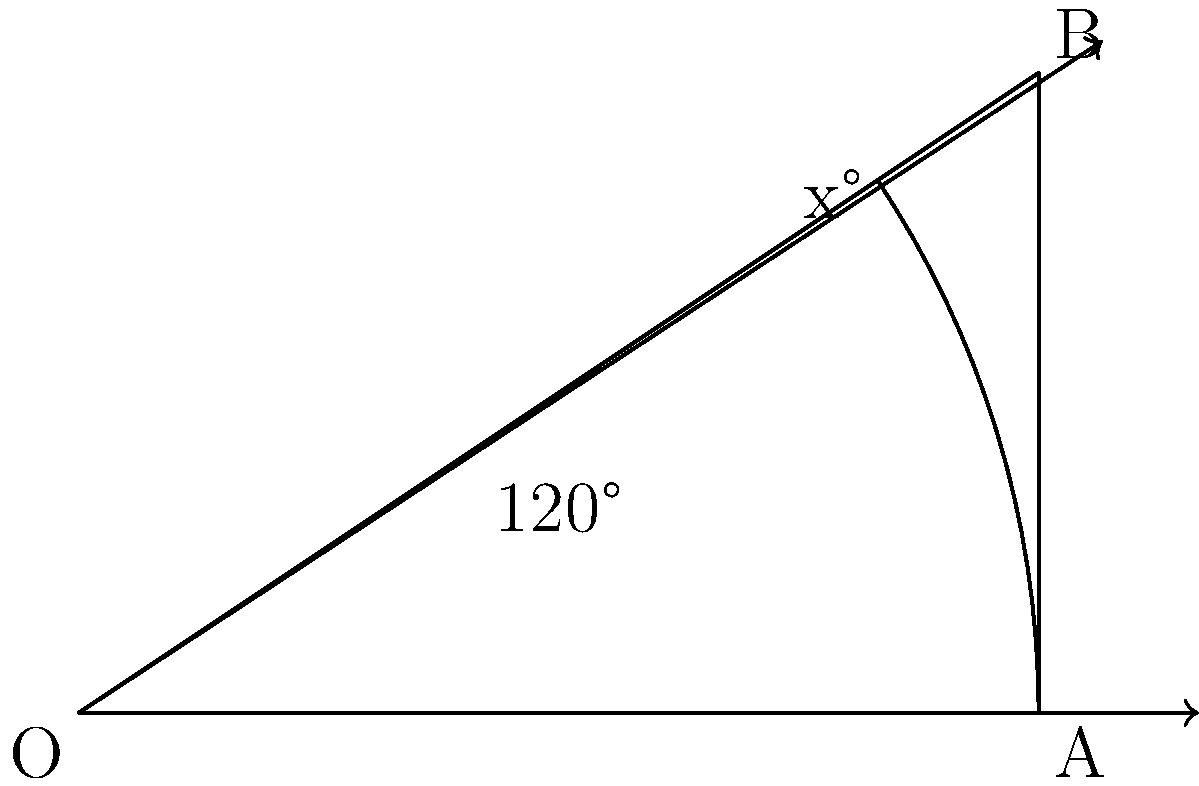In your latest VR game, you need to calculate the field of view (FOV) angle for a new headset. Given that the horizontal FOV is 120° and the aspect ratio of the display is 3:2, what is the vertical FOV angle (x°) to the nearest whole degree? Let's approach this step-by-step:

1) In a VR headset, the FOV forms a triangle. The horizontal FOV is the base angle, and we need to find the vertical angle.

2) The aspect ratio of 3:2 means that for every 3 units horizontally, there are 2 units vertically.

3) We can use the tangent function to relate these sides:

   $\tan(\frac{x}{2}) = \frac{\text{opposite}}{\text{adjacent}} = \frac{2}{3}$

4) The full horizontal FOV is 120°, so half of it is 60°. We can use this to set up an equation:

   $\tan(60°) = \frac{3}{\text{adjacent}}$

5) Solving for the adjacent side:

   $\text{adjacent} = \frac{3}{\tan(60°)} \approx 1.732$

6) Now we can find x:

   $x = 2 \cdot \arctan(\frac{2}{1.732}) \approx 67.38°$

7) Rounding to the nearest whole degree gives us 67°.
Answer: 67° 